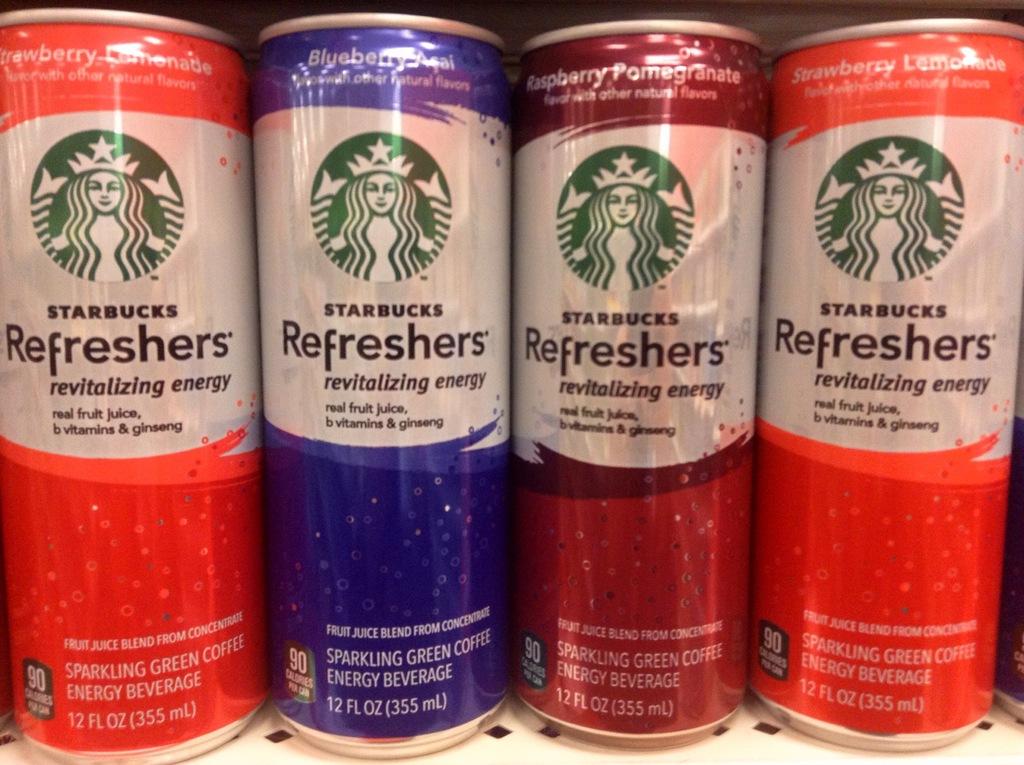What brand is on the cans of energy drinks?
Keep it short and to the point. Starbucks. 